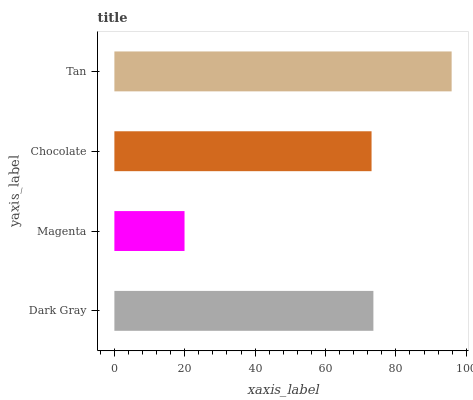Is Magenta the minimum?
Answer yes or no. Yes. Is Tan the maximum?
Answer yes or no. Yes. Is Chocolate the minimum?
Answer yes or no. No. Is Chocolate the maximum?
Answer yes or no. No. Is Chocolate greater than Magenta?
Answer yes or no. Yes. Is Magenta less than Chocolate?
Answer yes or no. Yes. Is Magenta greater than Chocolate?
Answer yes or no. No. Is Chocolate less than Magenta?
Answer yes or no. No. Is Dark Gray the high median?
Answer yes or no. Yes. Is Chocolate the low median?
Answer yes or no. Yes. Is Magenta the high median?
Answer yes or no. No. Is Dark Gray the low median?
Answer yes or no. No. 